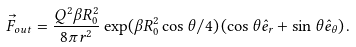Convert formula to latex. <formula><loc_0><loc_0><loc_500><loc_500>\vec { F } _ { o u t } = \frac { Q ^ { 2 } \beta R _ { 0 } ^ { 2 } } { 8 \pi r ^ { 2 } } \exp ( \beta R _ { 0 } ^ { 2 } \cos \theta / 4 ) \left ( \cos \theta \hat { e } _ { r } + \sin \theta \hat { e } _ { \theta } \right ) .</formula> 